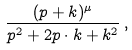<formula> <loc_0><loc_0><loc_500><loc_500>\frac { ( p + k ) ^ { \mu } } { p ^ { 2 } + 2 p \cdot k + k ^ { 2 } } \, ,</formula> 